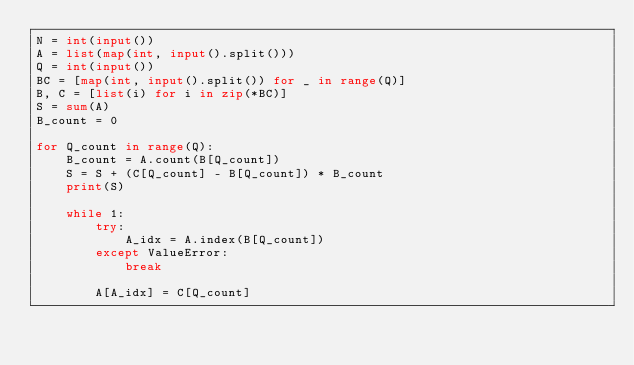<code> <loc_0><loc_0><loc_500><loc_500><_Python_>N = int(input())
A = list(map(int, input().split()))
Q = int(input())
BC = [map(int, input().split()) for _ in range(Q)]
B, C = [list(i) for i in zip(*BC)]
S = sum(A)
B_count = 0

for Q_count in range(Q):
    B_count = A.count(B[Q_count])
    S = S + (C[Q_count] - B[Q_count]) * B_count
    print(S)

    while 1:
        try:
            A_idx = A.index(B[Q_count])
        except ValueError:
            break

        A[A_idx] = C[Q_count]

</code> 